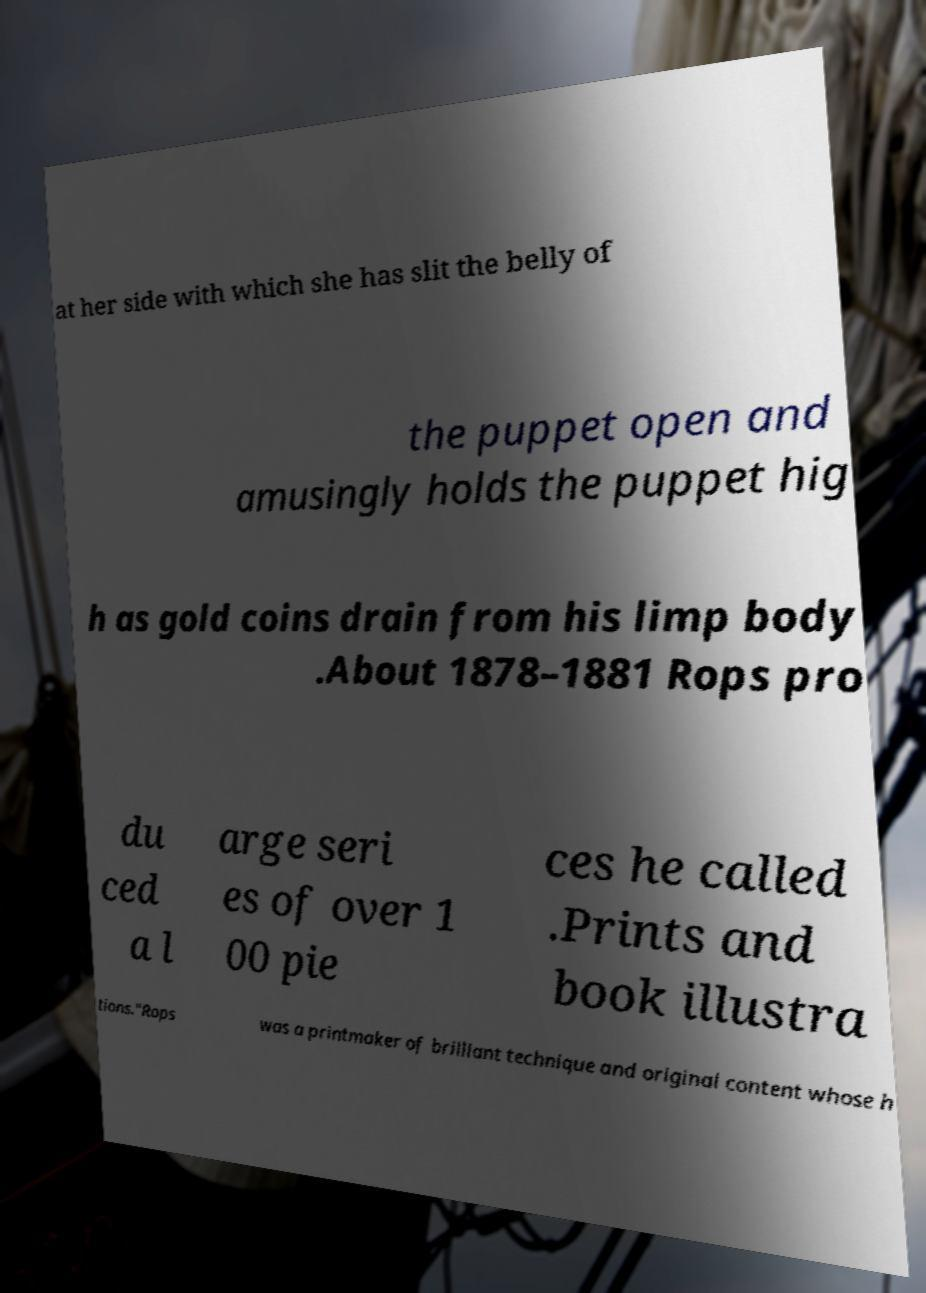Please read and relay the text visible in this image. What does it say? at her side with which she has slit the belly of the puppet open and amusingly holds the puppet hig h as gold coins drain from his limp body .About 1878–1881 Rops pro du ced a l arge seri es of over 1 00 pie ces he called .Prints and book illustra tions."Rops was a printmaker of brilliant technique and original content whose h 